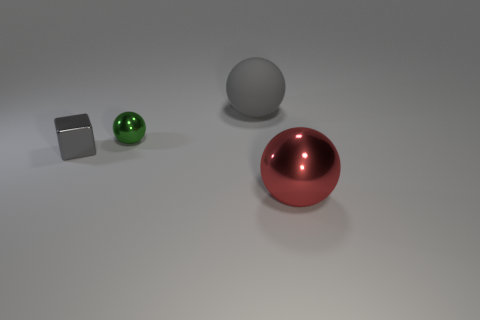There is a big object on the left side of the large shiny ball; is its shape the same as the green thing that is behind the red object?
Make the answer very short. Yes. What is the size of the ball to the right of the big gray rubber object?
Provide a succinct answer. Large. What is the size of the metallic ball behind the sphere that is in front of the green ball?
Ensure brevity in your answer.  Small. Are there more big blue rubber balls than tiny balls?
Your answer should be very brief. No. Is the number of green balls that are behind the gray matte ball greater than the number of tiny spheres that are to the right of the big red metal object?
Provide a short and direct response. No. What is the size of the thing that is both in front of the green ball and on the left side of the big matte sphere?
Offer a very short reply. Small. What number of gray metal cubes have the same size as the gray matte thing?
Provide a succinct answer. 0. What material is the big sphere that is the same color as the cube?
Keep it short and to the point. Rubber. There is a small object on the left side of the green object; is its shape the same as the large gray rubber thing?
Provide a succinct answer. No. Are there fewer small cubes to the right of the large matte object than red things?
Make the answer very short. Yes. 